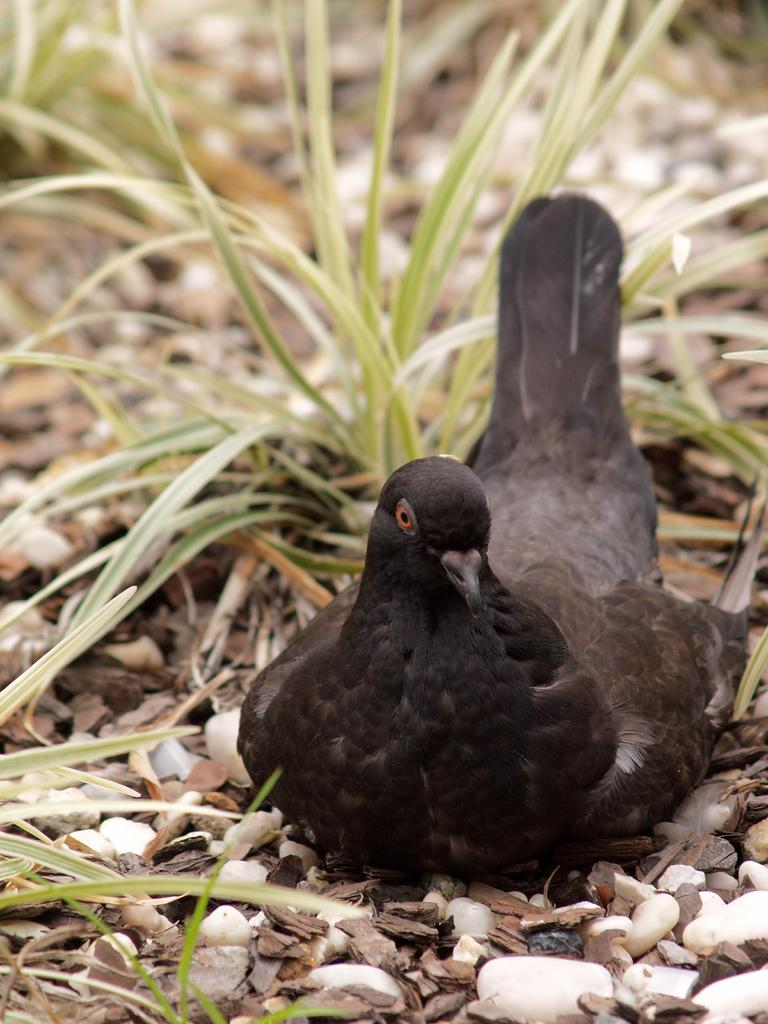What type of animal is in the image? There is a bird in the image. Where is the bird located? The bird is on stones. What can be seen in the background behind the bird? There is grass visible behind the bird. What type of education does the bird have in the image? There is no indication of the bird's education in the image. What religion does the bird follow in the image? There is no indication of the bird's religion in the image. 